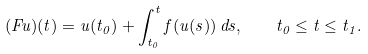<formula> <loc_0><loc_0><loc_500><loc_500>( F u ) ( t ) = u ( t _ { 0 } ) + \int _ { t _ { 0 } } ^ { t } f ( u ( s ) ) \, d s , \quad t _ { 0 } \leq t \leq t _ { 1 } .</formula> 